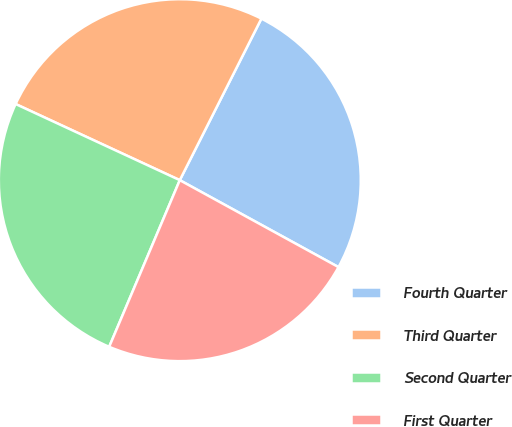Convert chart to OTSL. <chart><loc_0><loc_0><loc_500><loc_500><pie_chart><fcel>Fourth Quarter<fcel>Third Quarter<fcel>Second Quarter<fcel>First Quarter<nl><fcel>25.53%<fcel>25.53%<fcel>25.53%<fcel>23.4%<nl></chart> 